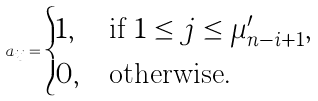<formula> <loc_0><loc_0><loc_500><loc_500>a _ { i j } = \begin{cases} 1 , & \text {if $1 \leq j\leq \mu^{\prime}_{n-i+1}$} , \\ 0 , & \text {otherwise} . \end{cases}</formula> 